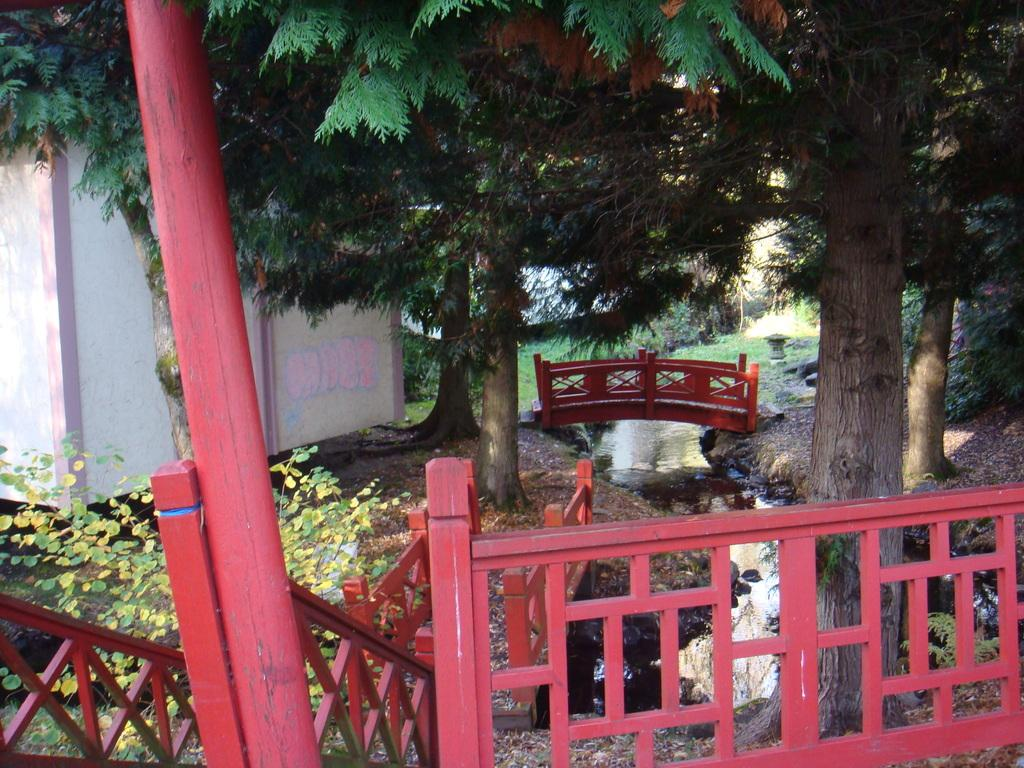How many wooden bridges can be seen in the image? There are two small wooden bridges in the image. What other structures are present in the image? There is a fence visible in the image. What natural element is present in the image? There is water visible in the image. What type of vegetation can be seen in the image? There are trees in the image. What might be located on the left side of the image? It appears to be a house on the left side of the image. Can you tell me how many times the person in the image folds their arms? There is no person present in the image, so it is not possible to determine how many times they fold their arms. What type of offer is being made in the image? There is no offer being made in the image; it features two wooden bridges, a fence, water, trees, and a house. 